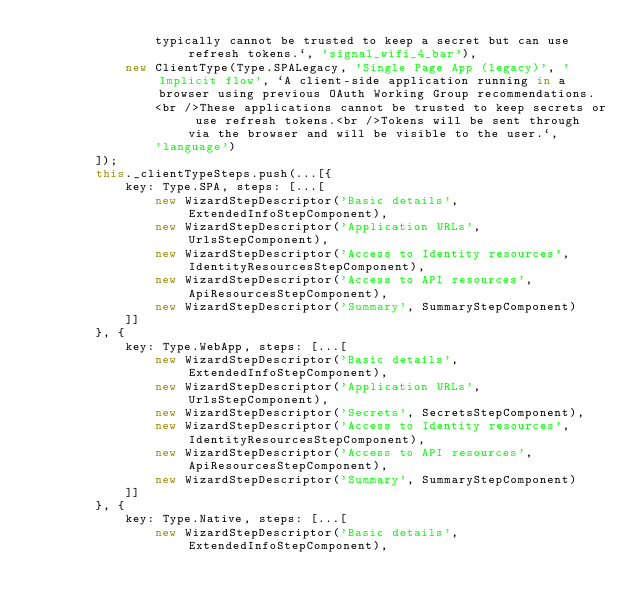Convert code to text. <code><loc_0><loc_0><loc_500><loc_500><_TypeScript_>                typically cannot be trusted to keep a secret but can use refresh tokens.`, 'signal_wifi_4_bar'),
            new ClientType(Type.SPALegacy, 'Single Page App (legacy)', 'Implicit flow', `A client-side application running in a browser using previous OAuth Working Group recommendations.
                <br />These applications cannot be trusted to keep secrets or use refresh tokens.<br />Tokens will be sent through via the browser and will be visible to the user.`,
                'language')
        ]);
        this._clientTypeSteps.push(...[{
            key: Type.SPA, steps: [...[
                new WizardStepDescriptor('Basic details', ExtendedInfoStepComponent),
                new WizardStepDescriptor('Application URLs', UrlsStepComponent),
                new WizardStepDescriptor('Access to Identity resources', IdentityResourcesStepComponent),
                new WizardStepDescriptor('Access to API resources', ApiResourcesStepComponent),
                new WizardStepDescriptor('Summary', SummaryStepComponent)
            ]]
        }, {
            key: Type.WebApp, steps: [...[
                new WizardStepDescriptor('Basic details', ExtendedInfoStepComponent),
                new WizardStepDescriptor('Application URLs', UrlsStepComponent),
                new WizardStepDescriptor('Secrets', SecretsStepComponent),
                new WizardStepDescriptor('Access to Identity resources', IdentityResourcesStepComponent),
                new WizardStepDescriptor('Access to API resources', ApiResourcesStepComponent),
                new WizardStepDescriptor('Summary', SummaryStepComponent)
            ]]
        }, {
            key: Type.Native, steps: [...[
                new WizardStepDescriptor('Basic details', ExtendedInfoStepComponent),</code> 